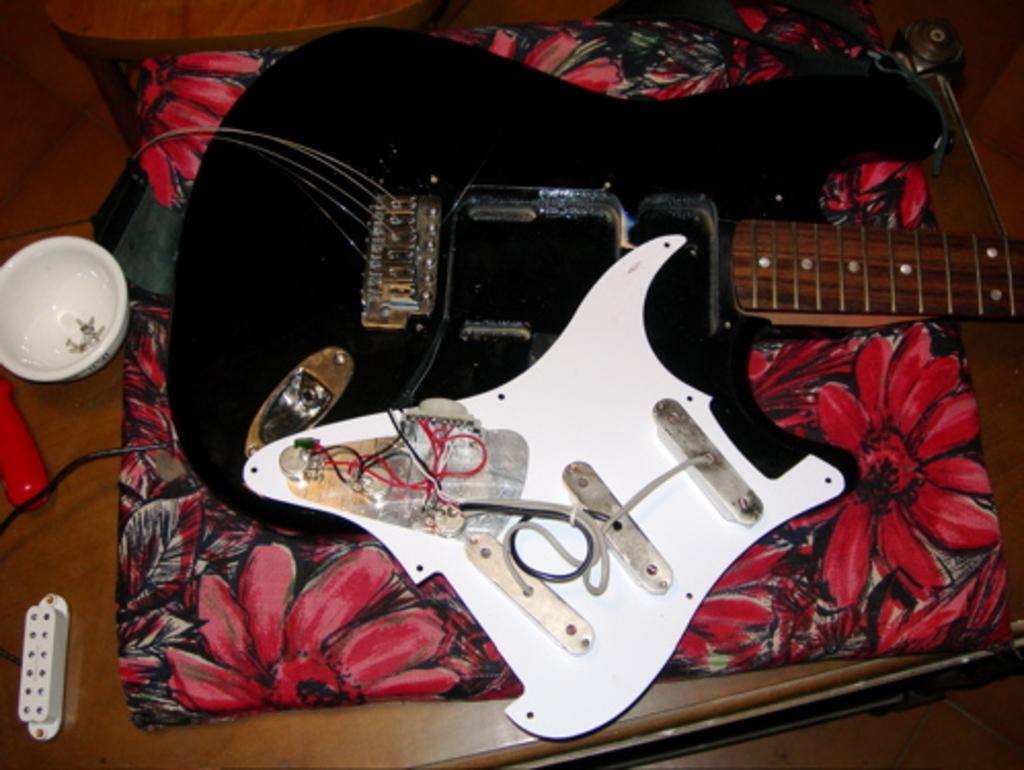Can you describe this image briefly? On floor there is a luggage and guitar. We can able to see bowl and chair. 